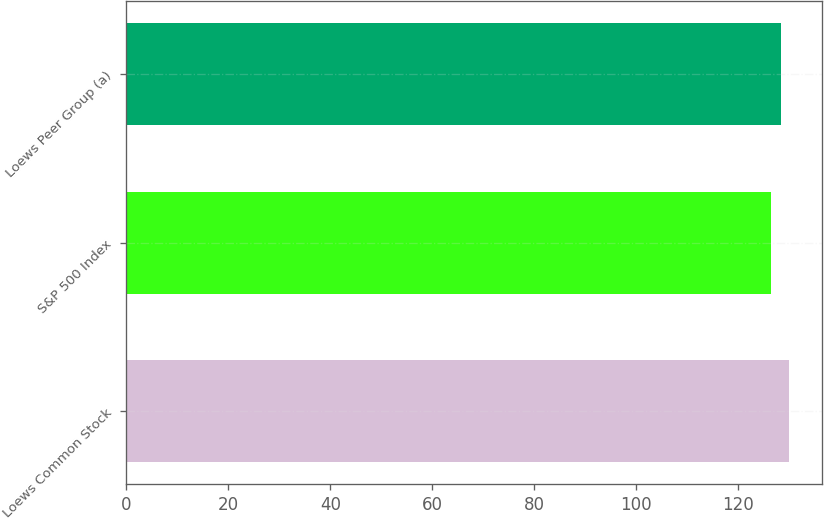<chart> <loc_0><loc_0><loc_500><loc_500><bar_chart><fcel>Loews Common Stock<fcel>S&P 500 Index<fcel>Loews Peer Group (a)<nl><fcel>129.84<fcel>126.46<fcel>128.27<nl></chart> 